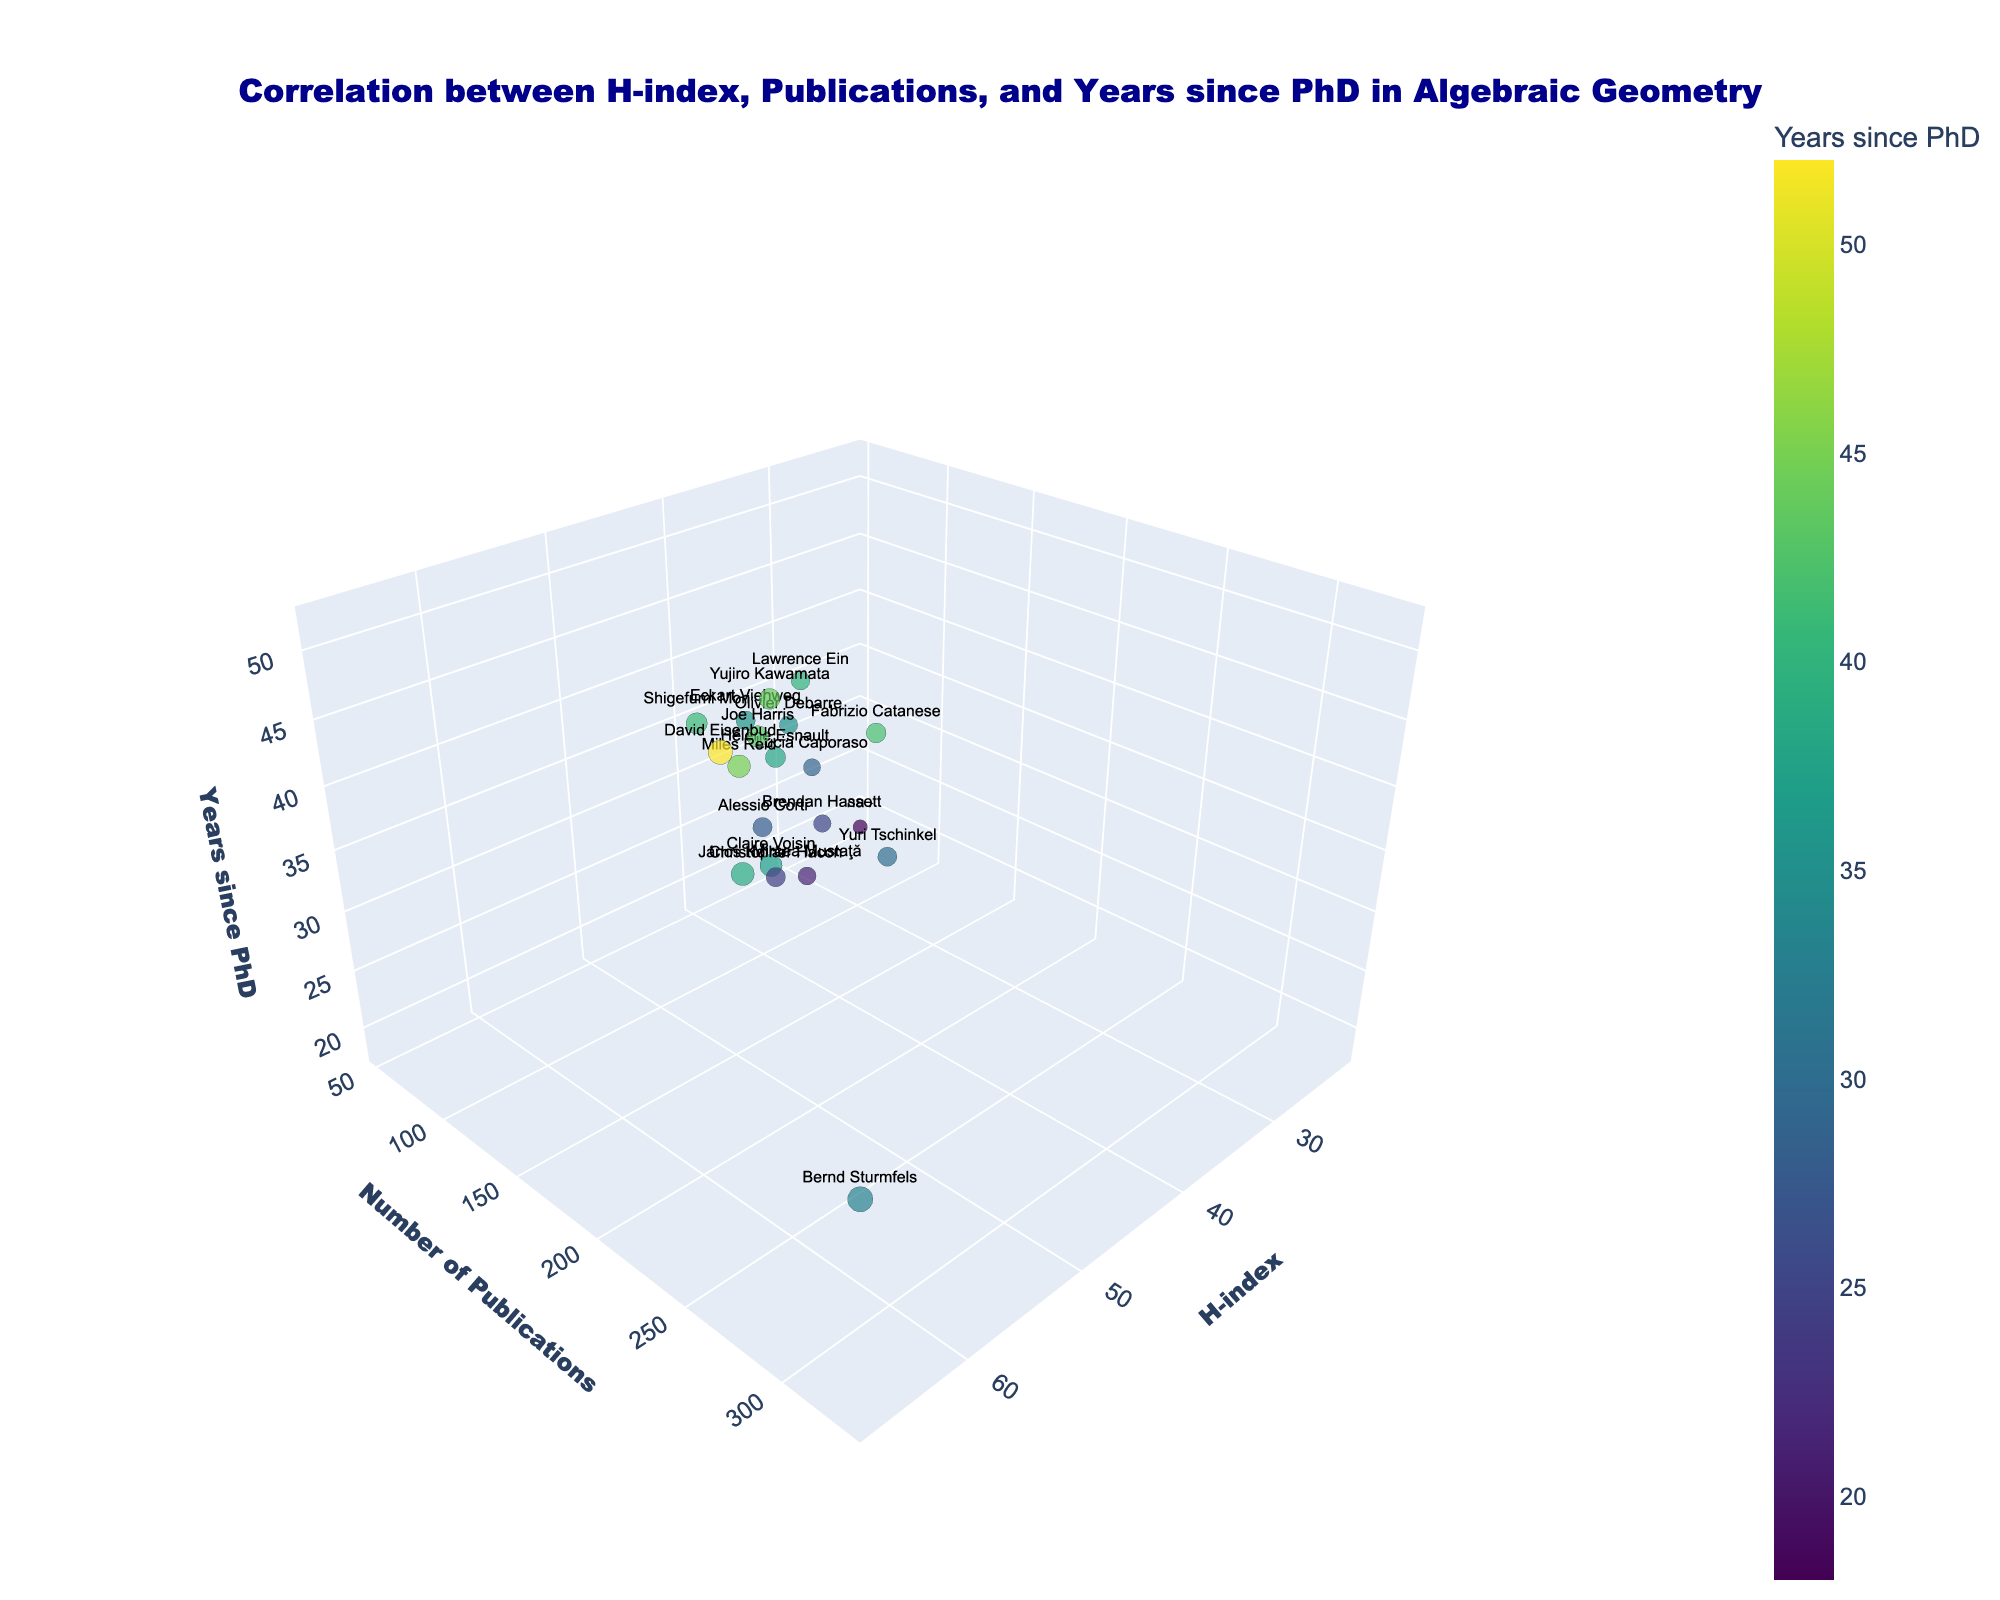What does the title of the figure indicate? The title of the figure provides a summary of the visualized data, indicating that the plot shows the correlation between a mathematician's H-index, number of publications, and years since obtaining their PhD, specifically for those in the field of algebraic geometry.
Answer: Correlation between H-index, Publications, and Years since PhD in Algebraic Geometry Which axis represents the number of publications? By looking at the axis labels, the Y-axis represents the number of publications.
Answer: Y-axis What color scheme is used to differentiate the mathematicians based on years since their PhD? The color scheme used is the 'Viridis' scale, which is a gradient from purple to yellow that represents the years since PhD.
Answer: Viridis Who has the highest number of publications among the mathematicians plotted? By examining the plot, Bernd Sturmfels stands out with the highest number of publications at 328.
Answer: Bernd Sturmfels What mathematician is located closest to the origin (0, 0, 0) of the plot? The point closest to the origin would have the smallest values for H-index, number of publications, and years since PhD. Carolina Araujo is plotted closest with an H-index of 22, 53 publications, and 18 years since PhD.
Answer: Carolina Araujo What is the difference in H-index between the mathematician with the highest and lowest H-index? The mathematician with the highest H-index is Bernd Sturmfels with 67, and the lowest H-index is Carolina Araujo with 22. The difference is 67 - 22 = 45.
Answer: 45 Which mathematician has the shortest number of years since receiving their PhD? Based on the Z-axis, the point that is lowest for 'Years since PhD' belongs to Carolina Araujo, with 18 years since her PhD.
Answer: Carolina Araujo Identify the mathematician who has approximately 100 publications and 39 years since their PhD. By cross-referencing points on the graph, the mathematician closest to 100 publications and 39 years since PhD is Lawrence Ein.
Answer: Lawrence Ein Compare the H-index of Alessio Corti and Shigefumi Mori, and state who has a higher H-index and by how much. Alessio Corti has an H-index of 39, and Shigefumi Mori has an H-index of 47. Mori has a higher H-index by 47 - 39 = 8.
Answer: Shigefumi Mori by 8 